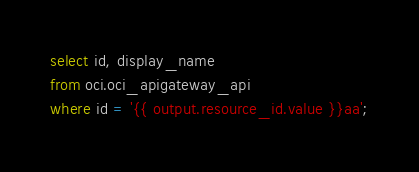<code> <loc_0><loc_0><loc_500><loc_500><_SQL_>select id, display_name
from oci.oci_apigateway_api
where id = '{{ output.resource_id.value }}aa';</code> 